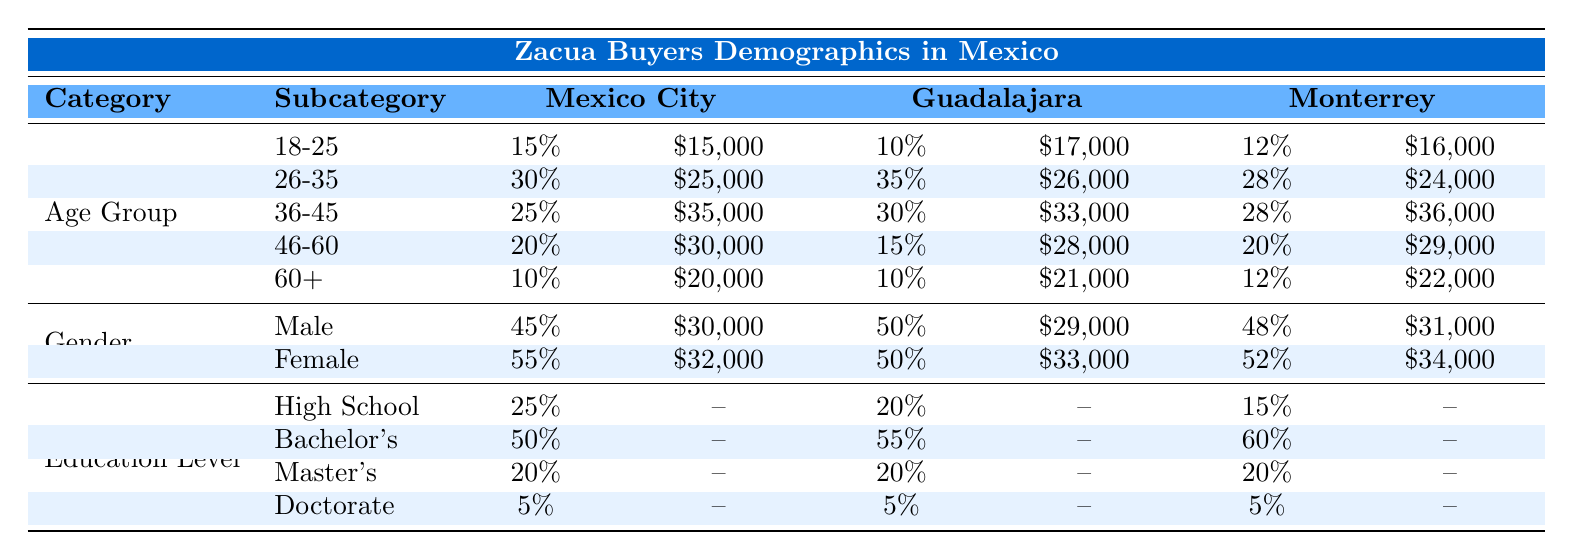What is the percentage of Zacua buyers in the 26-35 age group in Mexico City? The table shows the age group percentages for each region. In Mexico City, the percentage for the 26-35 age group is explicitly stated as 30%.
Answer: 30% What is the average income of female Zacua buyers in Guadalajara? In the Guadalajara section of the table under the Gender category, it shows that female buyers have an average income of 33,000 pesos.
Answer: 33,000 Is the percentage of Zacua buyers with a Doctorate higher in Guadalajara than in Monterrey? Both the Guadalajara and Monterrey sections state that the percentage of buyers with a Doctorate is 5%, making the two percentages equal. Thus, the claim is false.
Answer: No What is the total percentage of Zacua buyers aged 46-60 across all regions? To find this total, we sum the percentages from each region: Mexico City (20%) + Guadalajara (15%) + Monterrey (20%) = 55%.
Answer: 55% What is the average income of Zacua buyers in the 36-45 age group in Monterrey? For the 36-45 age group in Monterrey, the table indicates an average income of 36,000 pesos.
Answer: 36,000 In which age group is the highest percentage of Zacua buyers found in Guadalajara? In the Guadalajara section, the highest percentage is in the 26-35 age group at 35%. This is marked in the table as the highest value in their age group row.
Answer: 26-35 Are male Zacua buyers in Mexico City earning more than those in Monterrey? The average income for male buyers in Mexico City is 30,000 pesos, whereas in Monterrey, it is 31,000 pesos. Since 31,000 is greater than 30,000, the statement is false.
Answer: No What is the sum of the average incomes of all Zacua buyers in the 18-25 age group across the three regions? Adding the average incomes from all regions for the 18-25 age group yields: 15,000 (Mexico City) + 17,000 (Guadalajara) + 16,000 (Monterrey) = 48,000.
Answer: 48,000 What is the percentage of Zacua buyers with a Bachelor's degree in Monterrey? The table specifies that in Monterrey, 60% of Zacua buyers have a Bachelor's degree.
Answer: 60% 